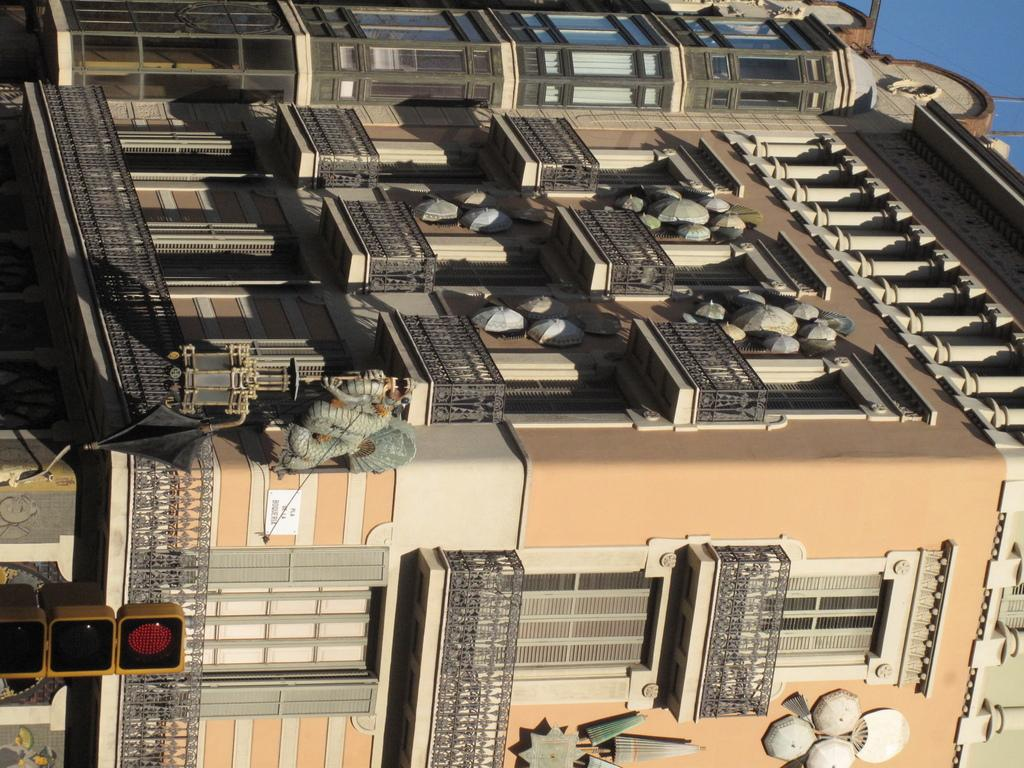What type of objects are used to control traffic in the image? There are traffic signals in the image. What structure can be seen in the image? There is a building in the image. What part of the natural environment is visible in the image? The sky is visible behind the building. Can you tell me how many chess pieces are on the roof of the building in the image? There are no chess pieces visible on the roof of the building in the image. What type of engine is powering the traffic signals in the image? The traffic signals in the image are powered by electricity, not an engine. 